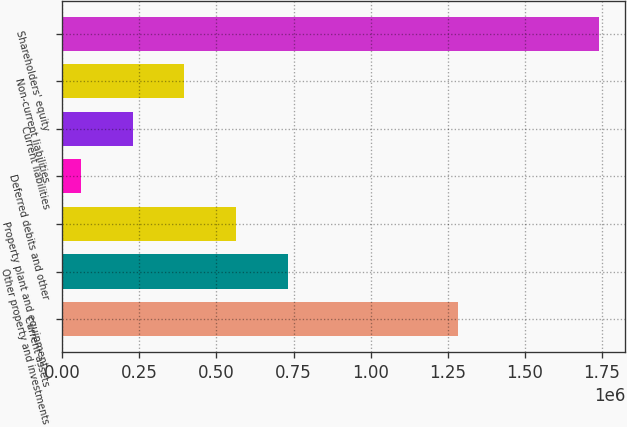Convert chart to OTSL. <chart><loc_0><loc_0><loc_500><loc_500><bar_chart><fcel>Current assets<fcel>Other property and investments<fcel>Property plant and equipment -<fcel>Deferred debits and other<fcel>Current liabilities<fcel>Non-current liabilities<fcel>Shareholders' equity<nl><fcel>1.28258e+06<fcel>731939<fcel>564112<fcel>60632<fcel>228459<fcel>396286<fcel>1.7389e+06<nl></chart> 